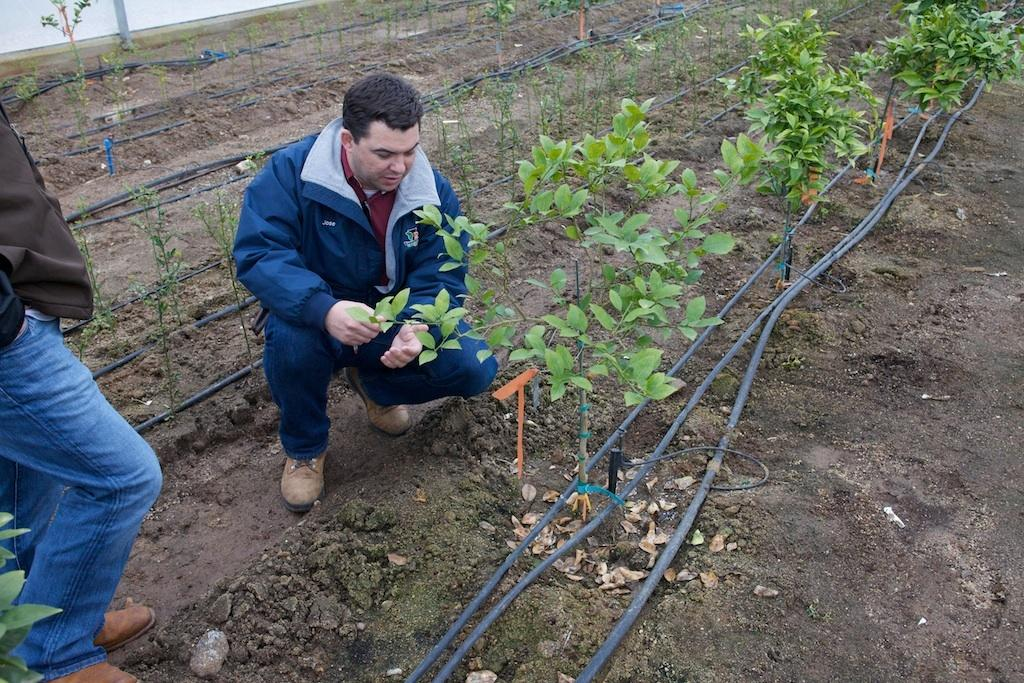What is the person in the image holding? The person in the image is holding a plant. What else can be seen in the image besides the person holding the plant? There are plants and pipes visible in the image. How many people are present in the image? There are people in the image, but the exact number is not specified. What type of fear can be seen on the person's face in the image? There is no indication of fear on the person's face in the image. What type of garden is visible in the image? There is no garden present in the image; it features a person holding a plant, plants, and pipes. 